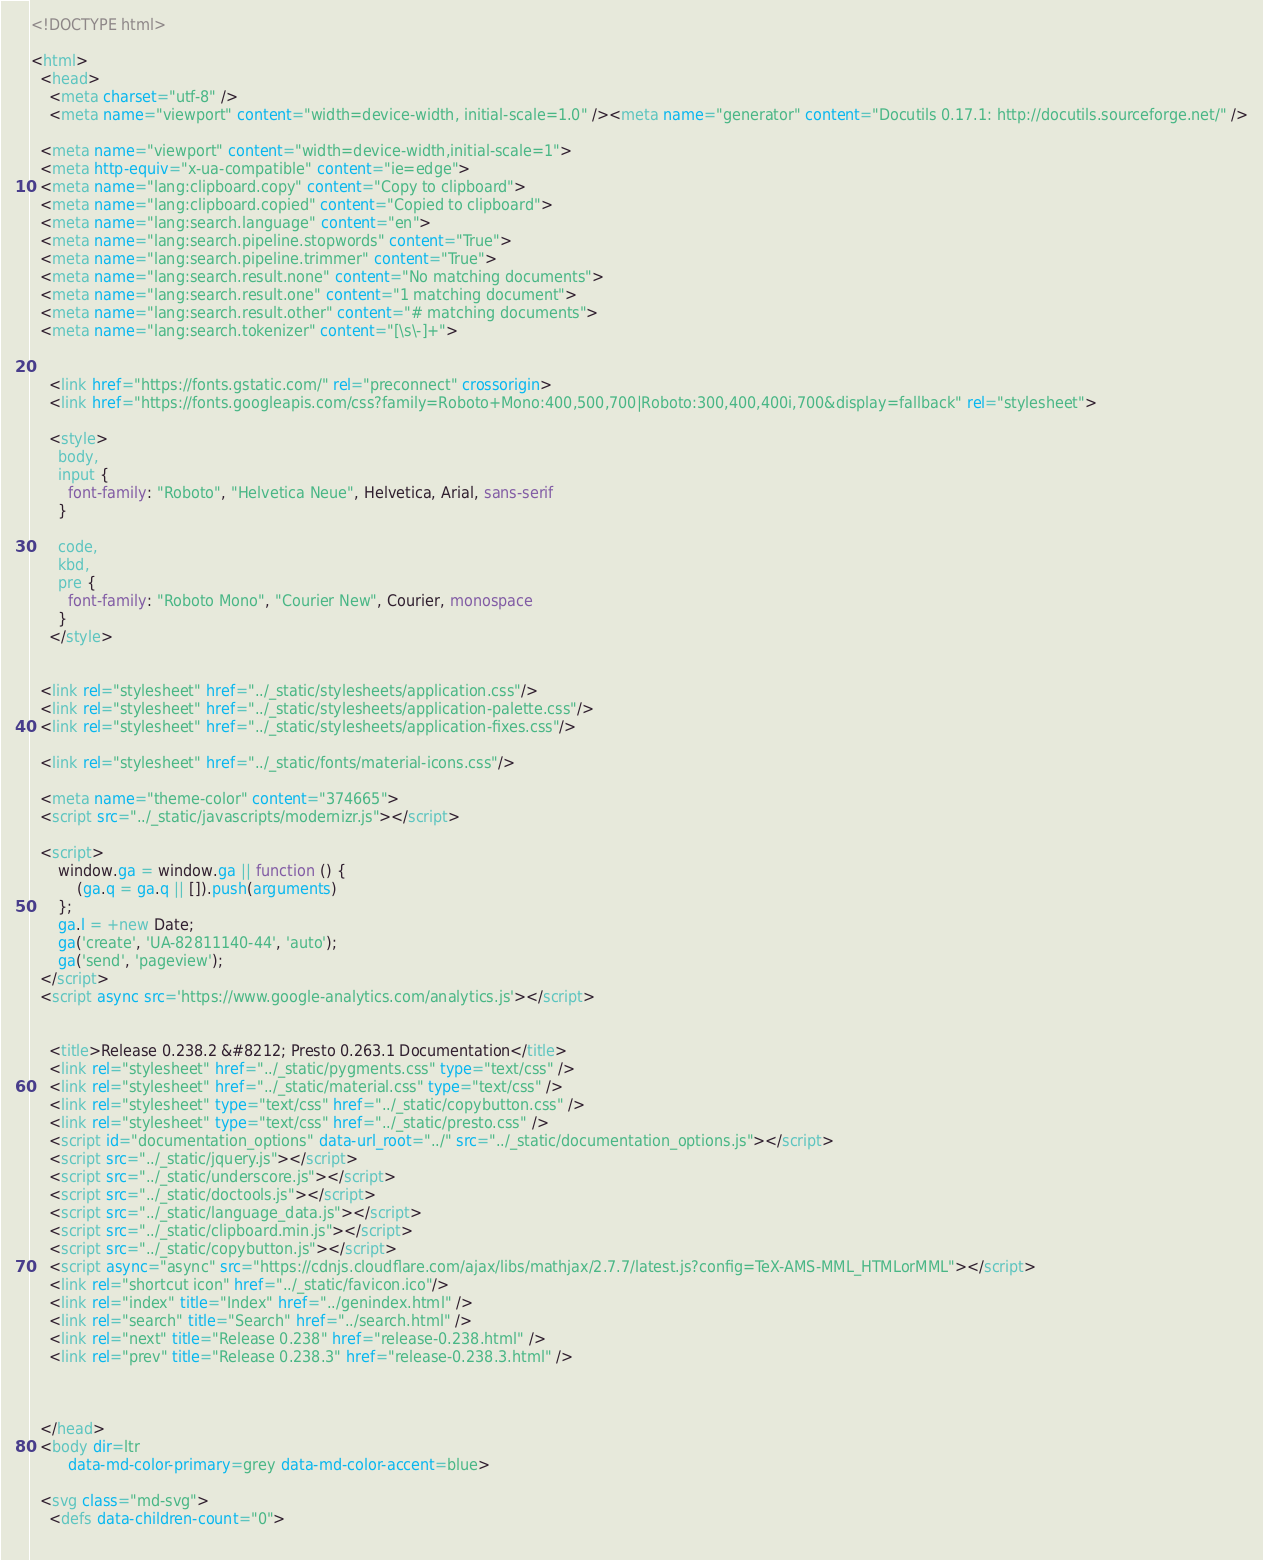<code> <loc_0><loc_0><loc_500><loc_500><_HTML_>
<!DOCTYPE html>

<html>
  <head>
    <meta charset="utf-8" />
    <meta name="viewport" content="width=device-width, initial-scale=1.0" /><meta name="generator" content="Docutils 0.17.1: http://docutils.sourceforge.net/" />

  <meta name="viewport" content="width=device-width,initial-scale=1">
  <meta http-equiv="x-ua-compatible" content="ie=edge">
  <meta name="lang:clipboard.copy" content="Copy to clipboard">
  <meta name="lang:clipboard.copied" content="Copied to clipboard">
  <meta name="lang:search.language" content="en">
  <meta name="lang:search.pipeline.stopwords" content="True">
  <meta name="lang:search.pipeline.trimmer" content="True">
  <meta name="lang:search.result.none" content="No matching documents">
  <meta name="lang:search.result.one" content="1 matching document">
  <meta name="lang:search.result.other" content="# matching documents">
  <meta name="lang:search.tokenizer" content="[\s\-]+">

  
    <link href="https://fonts.gstatic.com/" rel="preconnect" crossorigin>
    <link href="https://fonts.googleapis.com/css?family=Roboto+Mono:400,500,700|Roboto:300,400,400i,700&display=fallback" rel="stylesheet">

    <style>
      body,
      input {
        font-family: "Roboto", "Helvetica Neue", Helvetica, Arial, sans-serif
      }

      code,
      kbd,
      pre {
        font-family: "Roboto Mono", "Courier New", Courier, monospace
      }
    </style>
  

  <link rel="stylesheet" href="../_static/stylesheets/application.css"/>
  <link rel="stylesheet" href="../_static/stylesheets/application-palette.css"/>
  <link rel="stylesheet" href="../_static/stylesheets/application-fixes.css"/>
  
  <link rel="stylesheet" href="../_static/fonts/material-icons.css"/>
  
  <meta name="theme-color" content="374665">
  <script src="../_static/javascripts/modernizr.js"></script>
  
  <script>
      window.ga = window.ga || function () {
          (ga.q = ga.q || []).push(arguments)
      };
      ga.l = +new Date;
      ga('create', 'UA-82811140-44', 'auto');
      ga('send', 'pageview');
  </script>
  <script async src='https://www.google-analytics.com/analytics.js'></script>
  
  
    <title>Release 0.238.2 &#8212; Presto 0.263.1 Documentation</title>
    <link rel="stylesheet" href="../_static/pygments.css" type="text/css" />
    <link rel="stylesheet" href="../_static/material.css" type="text/css" />
    <link rel="stylesheet" type="text/css" href="../_static/copybutton.css" />
    <link rel="stylesheet" type="text/css" href="../_static/presto.css" />
    <script id="documentation_options" data-url_root="../" src="../_static/documentation_options.js"></script>
    <script src="../_static/jquery.js"></script>
    <script src="../_static/underscore.js"></script>
    <script src="../_static/doctools.js"></script>
    <script src="../_static/language_data.js"></script>
    <script src="../_static/clipboard.min.js"></script>
    <script src="../_static/copybutton.js"></script>
    <script async="async" src="https://cdnjs.cloudflare.com/ajax/libs/mathjax/2.7.7/latest.js?config=TeX-AMS-MML_HTMLorMML"></script>
    <link rel="shortcut icon" href="../_static/favicon.ico"/>
    <link rel="index" title="Index" href="../genindex.html" />
    <link rel="search" title="Search" href="../search.html" />
    <link rel="next" title="Release 0.238" href="release-0.238.html" />
    <link rel="prev" title="Release 0.238.3" href="release-0.238.3.html" />
  
   

  </head>
  <body dir=ltr
        data-md-color-primary=grey data-md-color-accent=blue>
  
  <svg class="md-svg">
    <defs data-children-count="0">
      </code> 